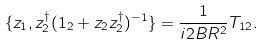<formula> <loc_0><loc_0><loc_500><loc_500>\{ z _ { 1 } , z _ { 2 } ^ { \dagger } ( 1 _ { 2 } + z _ { 2 } z _ { 2 } ^ { \dagger } ) ^ { - 1 } \} = \frac { 1 } { i 2 B R ^ { 2 } } T _ { 1 2 } .</formula> 